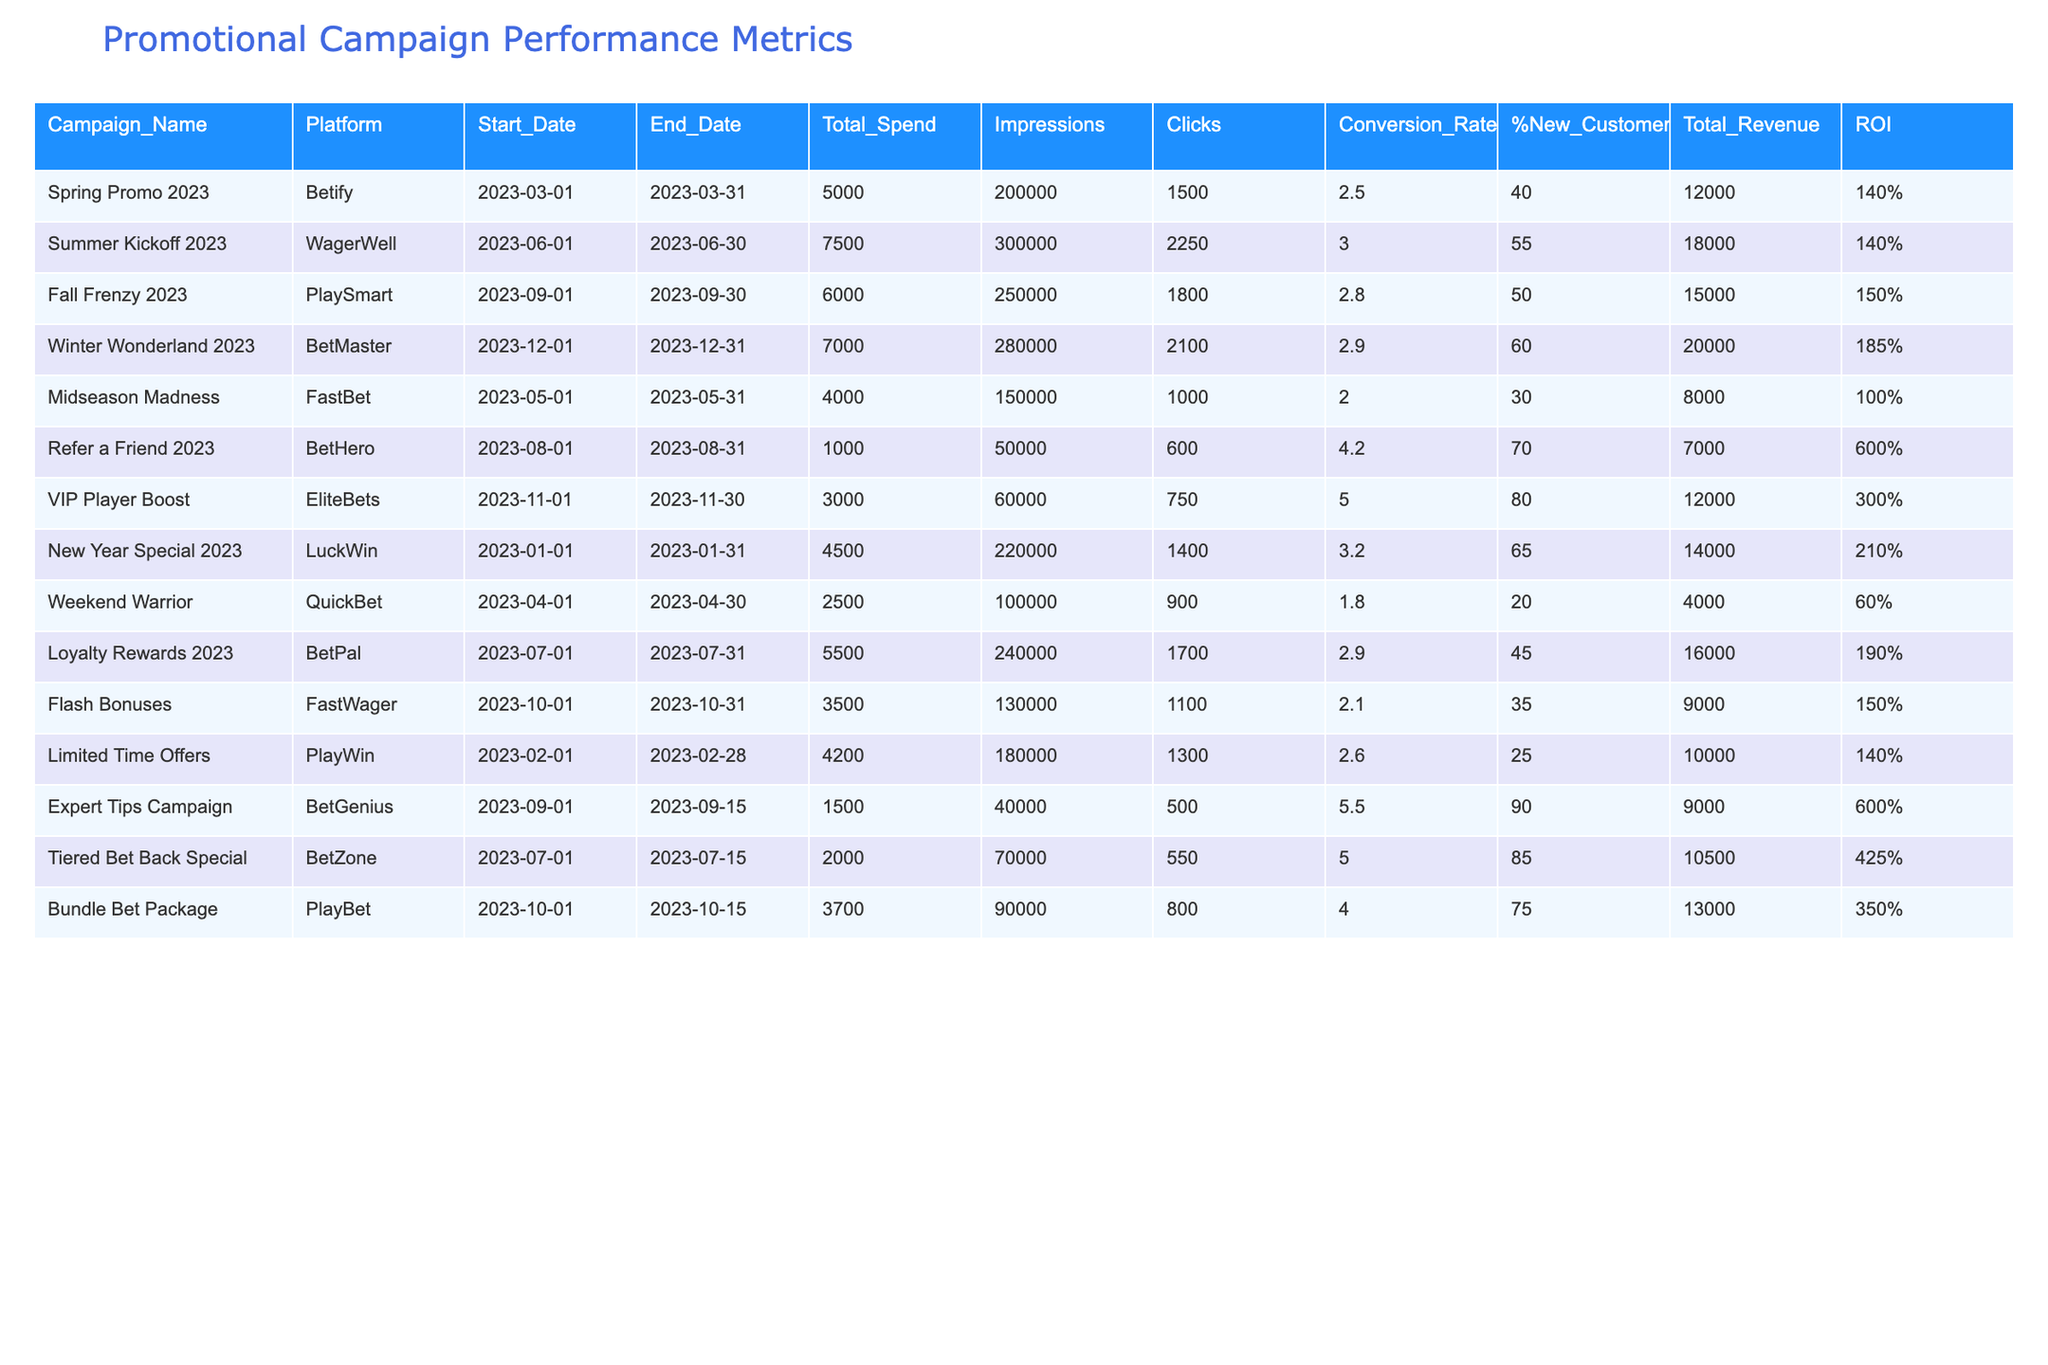What is the total revenue generated from the "Winter Wonderland 2023" campaign? The "Winter Wonderland 2023" campaign generated a total revenue of $20,000, as indicated in the table under the Total_Revenue column for that campaign.
Answer: $20,000 What is the ROI for the "Refer a Friend 2023" campaign? The ROI for the "Refer a Friend 2023" campaign is 600%, as shown in the ROI column corresponding to that campaign.
Answer: 600% Which campaign had the highest conversion rate? The "Expert Tips Campaign" had the highest conversion rate of 5.5%, which can be found in the Conversion_Rate column.
Answer: 5.5% What is the average Total Spend across all campaigns? To find the average Total Spend, we sum the Total Spend values ($5,000 + $7,500 + $6,000 + $7,000 + $4,000 + $1,000 + $3,000 + $4,500 + $2,500 + $5,500 + $3,500 + $4,200 + $1,500 + $2,000 + $3,700) = $56,500, then divide by the number of campaigns (15), giving us an average of $3,766.67.
Answer: $3,766.67 How many campaigns generated more than $15,000 in revenue? By examining the Total_Revenue column, the campaigns that generated more than $15,000 are: "Summer Kickoff 2023," "Winter Wonderland 2023," and "Loyalty Rewards 2023." That's a total of 3 campaigns.
Answer: 3 What is the difference in Total Spend between the "Fall Frenzy 2023" and "Midseason Madness" campaigns? The Total Spend for "Fall Frenzy 2023" is $6,000 and for "Midseason Madness" is $4,000. The difference is $6,000 - $4,000 = $2,000.
Answer: $2,000 Is the "Loyalty Rewards 2023" campaign more effective than the "Weekend Warrior" campaign in terms of ROI? The "Loyalty Rewards 2023" campaign has an ROI of 190%, while the "Weekend Warrior" campaign has an ROI of 60%. Since 190% is greater than 60%, "Loyalty Rewards 2023" is indeed more effective.
Answer: Yes What percentage of new customers did the "VIP Player Boost" campaign attract? The "VIP Player Boost" campaign attracted 80% new customers, which is stated in the %New_Customers column.
Answer: 80% Identify the campaign with the least Total Spend and provide its name. The campaign with the least Total Spend is "Refer a Friend 2023" with a spend of $1,000, as found in the Total_Spend column.
Answer: "Refer a Friend 2023" Calculate the average conversion rate of the campaigns that ran in the second half of the year (July to December). The campaigns in the second half are "Loyalty Rewards 2023" (2.9%), "Flash Bonuses" (2.1%), "Expert Tips Campaign" (5.5%), "VIP Player Boost" (5.0%), "Fall Frenzy 2023" (2.8%), and "Winter Wonderland 2023" (2.9%). The average is calculated as (2.9 + 2.1 + 5.5 + 5.0 + 2.8 + 2.9) / 6 = 3.35%.
Answer: 3.35% Which campaign had the most impressions, and what was that number? The campaign with the most impressions is "Summer Kickoff 2023," which had 300,000 impressions according to the Impressions column.
Answer: 300,000 